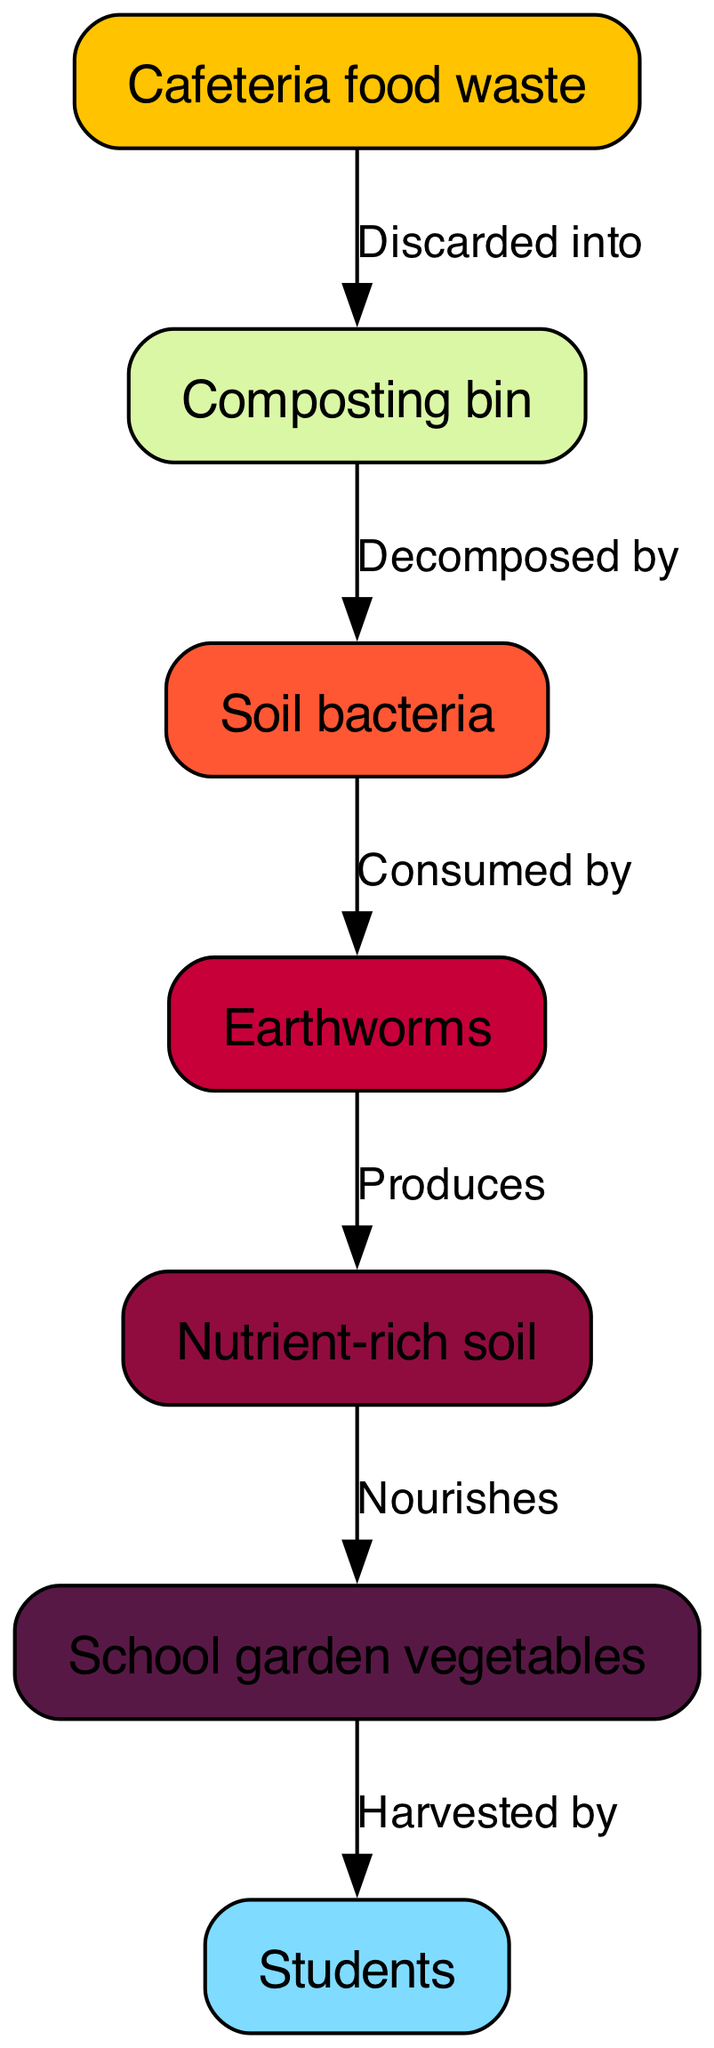What is the first node in the food chain? The first node in the food chain is 'Cafeteria food waste', which is where the process begins with discarded meals.
Answer: Cafeteria food waste How many nodes are in the diagram? By counting each unique item listed in the nodes section of the diagram, we find there are seven nodes present.
Answer: 7 What does 'Cafeteria food waste' get discarded into? The diagram indicates that 'Cafeteria food waste' is 'Discarded into' the 'Composting bin'.
Answer: Composting bin Which organism decomposes the compost? According to the information provided, 'Soil bacteria' are responsible for decomposing the compost.
Answer: Soil bacteria What type of soil is produced from decomposed food waste? The process leads to the creation of 'Nutrient-rich soil', as stated in the edges of the diagram.
Answer: Nutrient-rich soil How many connections (edges) are in the diagram? By counting the connections described in the edges section, we see there are six connections represented in the flow of the food chain.
Answer: 6 What do students consume from the school garden? The answer can be derived from the diagram where students 'Consume' the 'School garden vegetables'.
Answer: School garden vegetables How do earthworms contribute to the food chain? The diagram shows that 'Earthworms' are 'Consumed by' students, indicating their role as a source of nutrients in the food chain.
Answer: Consumed by What is the role of earthworms in the decomposition process? Earthworms are indirectly involved as they 'Decompose' the material further along with 'Soil bacteria' and help produce nutrient-rich soil.
Answer: Decomposed by How do 'Nutrient-rich soil' affect the school garden? The 'Nutrient-rich soil' 'Nourishes' the 'School garden vegetables', establishing a direct relationship that supports plant growth.
Answer: Nourishes 